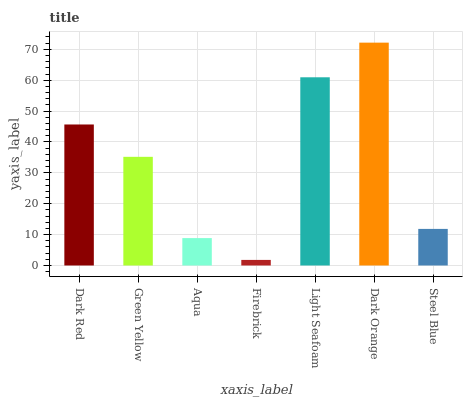Is Green Yellow the minimum?
Answer yes or no. No. Is Green Yellow the maximum?
Answer yes or no. No. Is Dark Red greater than Green Yellow?
Answer yes or no. Yes. Is Green Yellow less than Dark Red?
Answer yes or no. Yes. Is Green Yellow greater than Dark Red?
Answer yes or no. No. Is Dark Red less than Green Yellow?
Answer yes or no. No. Is Green Yellow the high median?
Answer yes or no. Yes. Is Green Yellow the low median?
Answer yes or no. Yes. Is Dark Red the high median?
Answer yes or no. No. Is Dark Orange the low median?
Answer yes or no. No. 